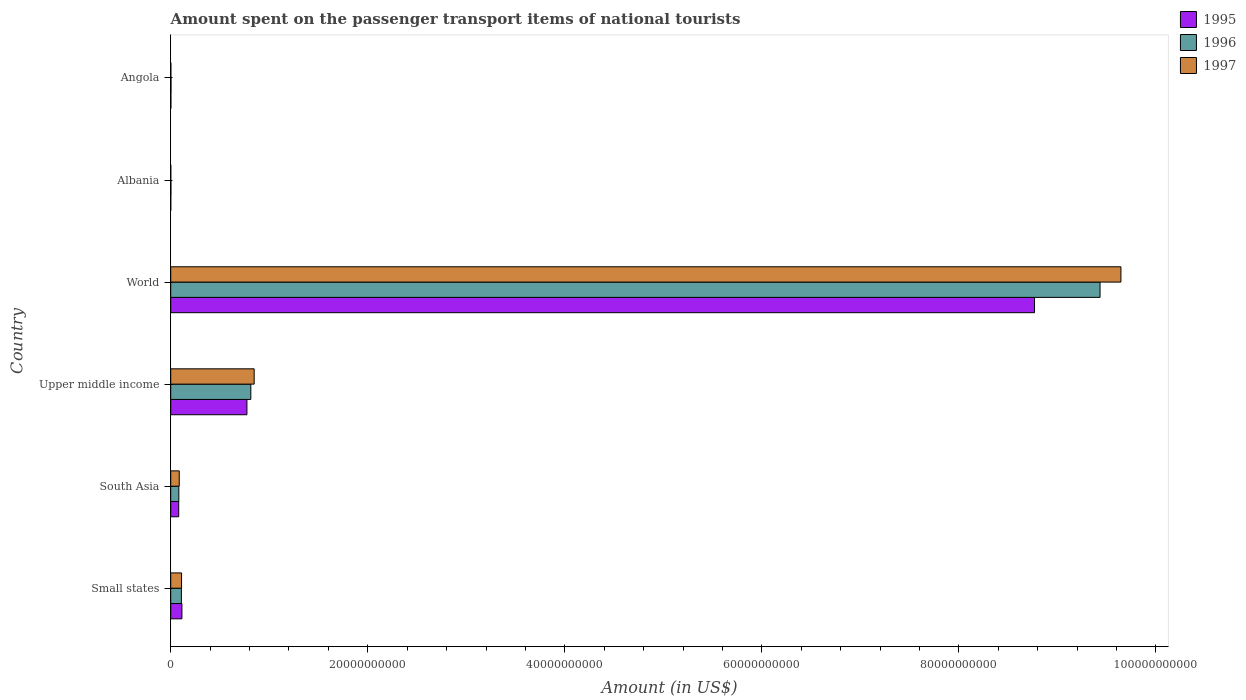How many groups of bars are there?
Ensure brevity in your answer.  6. Are the number of bars on each tick of the Y-axis equal?
Provide a succinct answer. Yes. How many bars are there on the 5th tick from the bottom?
Keep it short and to the point. 3. What is the amount spent on the passenger transport items of national tourists in 1995 in Upper middle income?
Provide a succinct answer. 7.73e+09. Across all countries, what is the maximum amount spent on the passenger transport items of national tourists in 1995?
Offer a terse response. 8.77e+1. Across all countries, what is the minimum amount spent on the passenger transport items of national tourists in 1996?
Keep it short and to the point. 1.68e+07. In which country was the amount spent on the passenger transport items of national tourists in 1996 minimum?
Offer a terse response. Albania. What is the total amount spent on the passenger transport items of national tourists in 1997 in the graph?
Your response must be concise. 1.07e+11. What is the difference between the amount spent on the passenger transport items of national tourists in 1996 in Albania and that in Upper middle income?
Your response must be concise. -8.11e+09. What is the difference between the amount spent on the passenger transport items of national tourists in 1997 in Upper middle income and the amount spent on the passenger transport items of national tourists in 1995 in Small states?
Ensure brevity in your answer.  7.33e+09. What is the average amount spent on the passenger transport items of national tourists in 1995 per country?
Your answer should be compact. 1.62e+1. What is the difference between the amount spent on the passenger transport items of national tourists in 1996 and amount spent on the passenger transport items of national tourists in 1997 in South Asia?
Provide a short and direct response. -4.25e+07. In how many countries, is the amount spent on the passenger transport items of national tourists in 1996 greater than 68000000000 US$?
Your response must be concise. 1. What is the ratio of the amount spent on the passenger transport items of national tourists in 1995 in Angola to that in South Asia?
Your answer should be compact. 0.02. Is the amount spent on the passenger transport items of national tourists in 1995 in Angola less than that in Upper middle income?
Give a very brief answer. Yes. Is the difference between the amount spent on the passenger transport items of national tourists in 1996 in Angola and Upper middle income greater than the difference between the amount spent on the passenger transport items of national tourists in 1997 in Angola and Upper middle income?
Your answer should be very brief. Yes. What is the difference between the highest and the second highest amount spent on the passenger transport items of national tourists in 1996?
Provide a succinct answer. 8.62e+1. What is the difference between the highest and the lowest amount spent on the passenger transport items of national tourists in 1995?
Offer a very short reply. 8.77e+1. Is the sum of the amount spent on the passenger transport items of national tourists in 1997 in Small states and World greater than the maximum amount spent on the passenger transport items of national tourists in 1996 across all countries?
Ensure brevity in your answer.  Yes. What does the 1st bar from the top in Small states represents?
Give a very brief answer. 1997. Is it the case that in every country, the sum of the amount spent on the passenger transport items of national tourists in 1996 and amount spent on the passenger transport items of national tourists in 1995 is greater than the amount spent on the passenger transport items of national tourists in 1997?
Your answer should be very brief. Yes. How many bars are there?
Give a very brief answer. 18. Are all the bars in the graph horizontal?
Your response must be concise. Yes. How many countries are there in the graph?
Your answer should be very brief. 6. What is the difference between two consecutive major ticks on the X-axis?
Your response must be concise. 2.00e+1. Are the values on the major ticks of X-axis written in scientific E-notation?
Your answer should be very brief. No. Does the graph contain any zero values?
Provide a short and direct response. No. Where does the legend appear in the graph?
Your response must be concise. Top right. How many legend labels are there?
Offer a very short reply. 3. What is the title of the graph?
Your response must be concise. Amount spent on the passenger transport items of national tourists. What is the label or title of the Y-axis?
Make the answer very short. Country. What is the Amount (in US$) of 1995 in Small states?
Your response must be concise. 1.14e+09. What is the Amount (in US$) of 1996 in Small states?
Ensure brevity in your answer.  1.08e+09. What is the Amount (in US$) of 1997 in Small states?
Provide a succinct answer. 1.10e+09. What is the Amount (in US$) in 1995 in South Asia?
Keep it short and to the point. 8.12e+08. What is the Amount (in US$) in 1996 in South Asia?
Your answer should be compact. 8.23e+08. What is the Amount (in US$) in 1997 in South Asia?
Ensure brevity in your answer.  8.66e+08. What is the Amount (in US$) of 1995 in Upper middle income?
Your answer should be very brief. 7.73e+09. What is the Amount (in US$) of 1996 in Upper middle income?
Give a very brief answer. 8.13e+09. What is the Amount (in US$) of 1997 in Upper middle income?
Provide a succinct answer. 8.47e+09. What is the Amount (in US$) in 1995 in World?
Your response must be concise. 8.77e+1. What is the Amount (in US$) in 1996 in World?
Make the answer very short. 9.43e+1. What is the Amount (in US$) in 1997 in World?
Keep it short and to the point. 9.64e+1. What is the Amount (in US$) of 1995 in Albania?
Your answer should be compact. 5.40e+06. What is the Amount (in US$) of 1996 in Albania?
Offer a very short reply. 1.68e+07. What is the Amount (in US$) of 1997 in Albania?
Your answer should be compact. 6.60e+06. What is the Amount (in US$) in 1995 in Angola?
Provide a short and direct response. 1.70e+07. What is the Amount (in US$) of 1996 in Angola?
Make the answer very short. 2.90e+07. What is the Amount (in US$) in 1997 in Angola?
Your response must be concise. 1.50e+07. Across all countries, what is the maximum Amount (in US$) in 1995?
Keep it short and to the point. 8.77e+1. Across all countries, what is the maximum Amount (in US$) of 1996?
Keep it short and to the point. 9.43e+1. Across all countries, what is the maximum Amount (in US$) in 1997?
Offer a terse response. 9.64e+1. Across all countries, what is the minimum Amount (in US$) of 1995?
Provide a succinct answer. 5.40e+06. Across all countries, what is the minimum Amount (in US$) in 1996?
Provide a short and direct response. 1.68e+07. Across all countries, what is the minimum Amount (in US$) in 1997?
Your answer should be very brief. 6.60e+06. What is the total Amount (in US$) in 1995 in the graph?
Your answer should be compact. 9.74e+1. What is the total Amount (in US$) of 1996 in the graph?
Keep it short and to the point. 1.04e+11. What is the total Amount (in US$) in 1997 in the graph?
Provide a succinct answer. 1.07e+11. What is the difference between the Amount (in US$) in 1995 in Small states and that in South Asia?
Offer a very short reply. 3.25e+08. What is the difference between the Amount (in US$) in 1996 in Small states and that in South Asia?
Give a very brief answer. 2.60e+08. What is the difference between the Amount (in US$) in 1997 in Small states and that in South Asia?
Your response must be concise. 2.35e+08. What is the difference between the Amount (in US$) in 1995 in Small states and that in Upper middle income?
Give a very brief answer. -6.60e+09. What is the difference between the Amount (in US$) of 1996 in Small states and that in Upper middle income?
Provide a succinct answer. -7.05e+09. What is the difference between the Amount (in US$) in 1997 in Small states and that in Upper middle income?
Provide a short and direct response. -7.37e+09. What is the difference between the Amount (in US$) in 1995 in Small states and that in World?
Your response must be concise. -8.65e+1. What is the difference between the Amount (in US$) of 1996 in Small states and that in World?
Offer a terse response. -9.32e+1. What is the difference between the Amount (in US$) of 1997 in Small states and that in World?
Provide a succinct answer. -9.53e+1. What is the difference between the Amount (in US$) of 1995 in Small states and that in Albania?
Make the answer very short. 1.13e+09. What is the difference between the Amount (in US$) in 1996 in Small states and that in Albania?
Your answer should be very brief. 1.07e+09. What is the difference between the Amount (in US$) of 1997 in Small states and that in Albania?
Your answer should be compact. 1.09e+09. What is the difference between the Amount (in US$) of 1995 in Small states and that in Angola?
Provide a short and direct response. 1.12e+09. What is the difference between the Amount (in US$) in 1996 in Small states and that in Angola?
Your answer should be very brief. 1.05e+09. What is the difference between the Amount (in US$) of 1997 in Small states and that in Angola?
Keep it short and to the point. 1.09e+09. What is the difference between the Amount (in US$) of 1995 in South Asia and that in Upper middle income?
Offer a terse response. -6.92e+09. What is the difference between the Amount (in US$) of 1996 in South Asia and that in Upper middle income?
Offer a terse response. -7.31e+09. What is the difference between the Amount (in US$) in 1997 in South Asia and that in Upper middle income?
Keep it short and to the point. -7.60e+09. What is the difference between the Amount (in US$) in 1995 in South Asia and that in World?
Keep it short and to the point. -8.69e+1. What is the difference between the Amount (in US$) of 1996 in South Asia and that in World?
Your response must be concise. -9.35e+1. What is the difference between the Amount (in US$) of 1997 in South Asia and that in World?
Offer a terse response. -9.56e+1. What is the difference between the Amount (in US$) of 1995 in South Asia and that in Albania?
Provide a short and direct response. 8.07e+08. What is the difference between the Amount (in US$) of 1996 in South Asia and that in Albania?
Keep it short and to the point. 8.06e+08. What is the difference between the Amount (in US$) of 1997 in South Asia and that in Albania?
Provide a succinct answer. 8.59e+08. What is the difference between the Amount (in US$) in 1995 in South Asia and that in Angola?
Ensure brevity in your answer.  7.95e+08. What is the difference between the Amount (in US$) in 1996 in South Asia and that in Angola?
Provide a short and direct response. 7.94e+08. What is the difference between the Amount (in US$) in 1997 in South Asia and that in Angola?
Offer a very short reply. 8.51e+08. What is the difference between the Amount (in US$) of 1995 in Upper middle income and that in World?
Your answer should be very brief. -7.99e+1. What is the difference between the Amount (in US$) in 1996 in Upper middle income and that in World?
Your response must be concise. -8.62e+1. What is the difference between the Amount (in US$) in 1997 in Upper middle income and that in World?
Keep it short and to the point. -8.80e+1. What is the difference between the Amount (in US$) of 1995 in Upper middle income and that in Albania?
Your answer should be compact. 7.73e+09. What is the difference between the Amount (in US$) in 1996 in Upper middle income and that in Albania?
Keep it short and to the point. 8.11e+09. What is the difference between the Amount (in US$) in 1997 in Upper middle income and that in Albania?
Give a very brief answer. 8.46e+09. What is the difference between the Amount (in US$) of 1995 in Upper middle income and that in Angola?
Provide a short and direct response. 7.72e+09. What is the difference between the Amount (in US$) of 1996 in Upper middle income and that in Angola?
Your response must be concise. 8.10e+09. What is the difference between the Amount (in US$) of 1997 in Upper middle income and that in Angola?
Keep it short and to the point. 8.45e+09. What is the difference between the Amount (in US$) in 1995 in World and that in Albania?
Offer a very short reply. 8.77e+1. What is the difference between the Amount (in US$) of 1996 in World and that in Albania?
Offer a very short reply. 9.43e+1. What is the difference between the Amount (in US$) in 1997 in World and that in Albania?
Provide a succinct answer. 9.64e+1. What is the difference between the Amount (in US$) in 1995 in World and that in Angola?
Offer a terse response. 8.77e+1. What is the difference between the Amount (in US$) in 1996 in World and that in Angola?
Your response must be concise. 9.43e+1. What is the difference between the Amount (in US$) in 1997 in World and that in Angola?
Offer a terse response. 9.64e+1. What is the difference between the Amount (in US$) in 1995 in Albania and that in Angola?
Your answer should be very brief. -1.16e+07. What is the difference between the Amount (in US$) of 1996 in Albania and that in Angola?
Offer a terse response. -1.22e+07. What is the difference between the Amount (in US$) of 1997 in Albania and that in Angola?
Your response must be concise. -8.40e+06. What is the difference between the Amount (in US$) of 1995 in Small states and the Amount (in US$) of 1996 in South Asia?
Your answer should be compact. 3.15e+08. What is the difference between the Amount (in US$) in 1995 in Small states and the Amount (in US$) in 1997 in South Asia?
Make the answer very short. 2.72e+08. What is the difference between the Amount (in US$) in 1996 in Small states and the Amount (in US$) in 1997 in South Asia?
Ensure brevity in your answer.  2.18e+08. What is the difference between the Amount (in US$) in 1995 in Small states and the Amount (in US$) in 1996 in Upper middle income?
Offer a terse response. -6.99e+09. What is the difference between the Amount (in US$) in 1995 in Small states and the Amount (in US$) in 1997 in Upper middle income?
Ensure brevity in your answer.  -7.33e+09. What is the difference between the Amount (in US$) of 1996 in Small states and the Amount (in US$) of 1997 in Upper middle income?
Provide a succinct answer. -7.39e+09. What is the difference between the Amount (in US$) in 1995 in Small states and the Amount (in US$) in 1996 in World?
Offer a very short reply. -9.32e+1. What is the difference between the Amount (in US$) of 1995 in Small states and the Amount (in US$) of 1997 in World?
Ensure brevity in your answer.  -9.53e+1. What is the difference between the Amount (in US$) of 1996 in Small states and the Amount (in US$) of 1997 in World?
Ensure brevity in your answer.  -9.54e+1. What is the difference between the Amount (in US$) of 1995 in Small states and the Amount (in US$) of 1996 in Albania?
Your answer should be compact. 1.12e+09. What is the difference between the Amount (in US$) of 1995 in Small states and the Amount (in US$) of 1997 in Albania?
Provide a short and direct response. 1.13e+09. What is the difference between the Amount (in US$) in 1996 in Small states and the Amount (in US$) in 1997 in Albania?
Provide a succinct answer. 1.08e+09. What is the difference between the Amount (in US$) in 1995 in Small states and the Amount (in US$) in 1996 in Angola?
Provide a succinct answer. 1.11e+09. What is the difference between the Amount (in US$) in 1995 in Small states and the Amount (in US$) in 1997 in Angola?
Give a very brief answer. 1.12e+09. What is the difference between the Amount (in US$) in 1996 in Small states and the Amount (in US$) in 1997 in Angola?
Offer a terse response. 1.07e+09. What is the difference between the Amount (in US$) of 1995 in South Asia and the Amount (in US$) of 1996 in Upper middle income?
Offer a terse response. -7.32e+09. What is the difference between the Amount (in US$) of 1995 in South Asia and the Amount (in US$) of 1997 in Upper middle income?
Offer a terse response. -7.66e+09. What is the difference between the Amount (in US$) of 1996 in South Asia and the Amount (in US$) of 1997 in Upper middle income?
Make the answer very short. -7.65e+09. What is the difference between the Amount (in US$) in 1995 in South Asia and the Amount (in US$) in 1996 in World?
Offer a terse response. -9.35e+1. What is the difference between the Amount (in US$) in 1995 in South Asia and the Amount (in US$) in 1997 in World?
Provide a short and direct response. -9.56e+1. What is the difference between the Amount (in US$) of 1996 in South Asia and the Amount (in US$) of 1997 in World?
Your response must be concise. -9.56e+1. What is the difference between the Amount (in US$) in 1995 in South Asia and the Amount (in US$) in 1996 in Albania?
Provide a short and direct response. 7.95e+08. What is the difference between the Amount (in US$) of 1995 in South Asia and the Amount (in US$) of 1997 in Albania?
Provide a succinct answer. 8.05e+08. What is the difference between the Amount (in US$) of 1996 in South Asia and the Amount (in US$) of 1997 in Albania?
Provide a succinct answer. 8.16e+08. What is the difference between the Amount (in US$) of 1995 in South Asia and the Amount (in US$) of 1996 in Angola?
Ensure brevity in your answer.  7.83e+08. What is the difference between the Amount (in US$) of 1995 in South Asia and the Amount (in US$) of 1997 in Angola?
Your answer should be compact. 7.97e+08. What is the difference between the Amount (in US$) in 1996 in South Asia and the Amount (in US$) in 1997 in Angola?
Keep it short and to the point. 8.08e+08. What is the difference between the Amount (in US$) of 1995 in Upper middle income and the Amount (in US$) of 1996 in World?
Provide a succinct answer. -8.66e+1. What is the difference between the Amount (in US$) of 1995 in Upper middle income and the Amount (in US$) of 1997 in World?
Give a very brief answer. -8.87e+1. What is the difference between the Amount (in US$) in 1996 in Upper middle income and the Amount (in US$) in 1997 in World?
Provide a succinct answer. -8.83e+1. What is the difference between the Amount (in US$) of 1995 in Upper middle income and the Amount (in US$) of 1996 in Albania?
Keep it short and to the point. 7.72e+09. What is the difference between the Amount (in US$) of 1995 in Upper middle income and the Amount (in US$) of 1997 in Albania?
Your answer should be very brief. 7.73e+09. What is the difference between the Amount (in US$) of 1996 in Upper middle income and the Amount (in US$) of 1997 in Albania?
Your answer should be very brief. 8.12e+09. What is the difference between the Amount (in US$) of 1995 in Upper middle income and the Amount (in US$) of 1996 in Angola?
Your answer should be very brief. 7.70e+09. What is the difference between the Amount (in US$) of 1995 in Upper middle income and the Amount (in US$) of 1997 in Angola?
Your answer should be compact. 7.72e+09. What is the difference between the Amount (in US$) of 1996 in Upper middle income and the Amount (in US$) of 1997 in Angola?
Keep it short and to the point. 8.12e+09. What is the difference between the Amount (in US$) of 1995 in World and the Amount (in US$) of 1996 in Albania?
Your answer should be very brief. 8.77e+1. What is the difference between the Amount (in US$) in 1995 in World and the Amount (in US$) in 1997 in Albania?
Ensure brevity in your answer.  8.77e+1. What is the difference between the Amount (in US$) in 1996 in World and the Amount (in US$) in 1997 in Albania?
Offer a terse response. 9.43e+1. What is the difference between the Amount (in US$) of 1995 in World and the Amount (in US$) of 1996 in Angola?
Provide a short and direct response. 8.76e+1. What is the difference between the Amount (in US$) of 1995 in World and the Amount (in US$) of 1997 in Angola?
Provide a succinct answer. 8.77e+1. What is the difference between the Amount (in US$) of 1996 in World and the Amount (in US$) of 1997 in Angola?
Make the answer very short. 9.43e+1. What is the difference between the Amount (in US$) of 1995 in Albania and the Amount (in US$) of 1996 in Angola?
Make the answer very short. -2.36e+07. What is the difference between the Amount (in US$) of 1995 in Albania and the Amount (in US$) of 1997 in Angola?
Provide a short and direct response. -9.60e+06. What is the difference between the Amount (in US$) in 1996 in Albania and the Amount (in US$) in 1997 in Angola?
Keep it short and to the point. 1.80e+06. What is the average Amount (in US$) of 1995 per country?
Offer a terse response. 1.62e+1. What is the average Amount (in US$) of 1996 per country?
Your response must be concise. 1.74e+1. What is the average Amount (in US$) of 1997 per country?
Your answer should be very brief. 1.78e+1. What is the difference between the Amount (in US$) in 1995 and Amount (in US$) in 1996 in Small states?
Make the answer very short. 5.44e+07. What is the difference between the Amount (in US$) in 1995 and Amount (in US$) in 1997 in Small states?
Your answer should be very brief. 3.69e+07. What is the difference between the Amount (in US$) of 1996 and Amount (in US$) of 1997 in Small states?
Ensure brevity in your answer.  -1.75e+07. What is the difference between the Amount (in US$) in 1995 and Amount (in US$) in 1996 in South Asia?
Your answer should be compact. -1.09e+07. What is the difference between the Amount (in US$) in 1995 and Amount (in US$) in 1997 in South Asia?
Provide a succinct answer. -5.35e+07. What is the difference between the Amount (in US$) in 1996 and Amount (in US$) in 1997 in South Asia?
Offer a very short reply. -4.25e+07. What is the difference between the Amount (in US$) of 1995 and Amount (in US$) of 1996 in Upper middle income?
Give a very brief answer. -3.97e+08. What is the difference between the Amount (in US$) in 1995 and Amount (in US$) in 1997 in Upper middle income?
Give a very brief answer. -7.36e+08. What is the difference between the Amount (in US$) of 1996 and Amount (in US$) of 1997 in Upper middle income?
Offer a very short reply. -3.39e+08. What is the difference between the Amount (in US$) of 1995 and Amount (in US$) of 1996 in World?
Make the answer very short. -6.65e+09. What is the difference between the Amount (in US$) of 1995 and Amount (in US$) of 1997 in World?
Provide a short and direct response. -8.77e+09. What is the difference between the Amount (in US$) of 1996 and Amount (in US$) of 1997 in World?
Offer a very short reply. -2.12e+09. What is the difference between the Amount (in US$) of 1995 and Amount (in US$) of 1996 in Albania?
Your response must be concise. -1.14e+07. What is the difference between the Amount (in US$) in 1995 and Amount (in US$) in 1997 in Albania?
Give a very brief answer. -1.20e+06. What is the difference between the Amount (in US$) in 1996 and Amount (in US$) in 1997 in Albania?
Make the answer very short. 1.02e+07. What is the difference between the Amount (in US$) of 1995 and Amount (in US$) of 1996 in Angola?
Provide a short and direct response. -1.20e+07. What is the difference between the Amount (in US$) in 1996 and Amount (in US$) in 1997 in Angola?
Your response must be concise. 1.40e+07. What is the ratio of the Amount (in US$) in 1995 in Small states to that in South Asia?
Offer a very short reply. 1.4. What is the ratio of the Amount (in US$) in 1996 in Small states to that in South Asia?
Give a very brief answer. 1.32. What is the ratio of the Amount (in US$) in 1997 in Small states to that in South Asia?
Your answer should be very brief. 1.27. What is the ratio of the Amount (in US$) of 1995 in Small states to that in Upper middle income?
Your answer should be compact. 0.15. What is the ratio of the Amount (in US$) of 1996 in Small states to that in Upper middle income?
Offer a very short reply. 0.13. What is the ratio of the Amount (in US$) of 1997 in Small states to that in Upper middle income?
Provide a succinct answer. 0.13. What is the ratio of the Amount (in US$) in 1995 in Small states to that in World?
Give a very brief answer. 0.01. What is the ratio of the Amount (in US$) in 1996 in Small states to that in World?
Keep it short and to the point. 0.01. What is the ratio of the Amount (in US$) of 1997 in Small states to that in World?
Offer a very short reply. 0.01. What is the ratio of the Amount (in US$) of 1995 in Small states to that in Albania?
Your answer should be compact. 210.65. What is the ratio of the Amount (in US$) of 1996 in Small states to that in Albania?
Your answer should be compact. 64.47. What is the ratio of the Amount (in US$) in 1997 in Small states to that in Albania?
Offer a very short reply. 166.76. What is the ratio of the Amount (in US$) of 1995 in Small states to that in Angola?
Your answer should be very brief. 66.91. What is the ratio of the Amount (in US$) of 1996 in Small states to that in Angola?
Offer a terse response. 37.35. What is the ratio of the Amount (in US$) in 1997 in Small states to that in Angola?
Offer a terse response. 73.37. What is the ratio of the Amount (in US$) in 1995 in South Asia to that in Upper middle income?
Give a very brief answer. 0.1. What is the ratio of the Amount (in US$) in 1996 in South Asia to that in Upper middle income?
Ensure brevity in your answer.  0.1. What is the ratio of the Amount (in US$) in 1997 in South Asia to that in Upper middle income?
Offer a terse response. 0.1. What is the ratio of the Amount (in US$) in 1995 in South Asia to that in World?
Provide a short and direct response. 0.01. What is the ratio of the Amount (in US$) in 1996 in South Asia to that in World?
Offer a very short reply. 0.01. What is the ratio of the Amount (in US$) of 1997 in South Asia to that in World?
Provide a short and direct response. 0.01. What is the ratio of the Amount (in US$) of 1995 in South Asia to that in Albania?
Give a very brief answer. 150.38. What is the ratio of the Amount (in US$) in 1996 in South Asia to that in Albania?
Offer a very short reply. 48.99. What is the ratio of the Amount (in US$) in 1997 in South Asia to that in Albania?
Keep it short and to the point. 131.14. What is the ratio of the Amount (in US$) in 1995 in South Asia to that in Angola?
Offer a very short reply. 47.77. What is the ratio of the Amount (in US$) of 1996 in South Asia to that in Angola?
Offer a terse response. 28.38. What is the ratio of the Amount (in US$) of 1997 in South Asia to that in Angola?
Your answer should be very brief. 57.7. What is the ratio of the Amount (in US$) of 1995 in Upper middle income to that in World?
Offer a very short reply. 0.09. What is the ratio of the Amount (in US$) in 1996 in Upper middle income to that in World?
Offer a terse response. 0.09. What is the ratio of the Amount (in US$) in 1997 in Upper middle income to that in World?
Keep it short and to the point. 0.09. What is the ratio of the Amount (in US$) of 1995 in Upper middle income to that in Albania?
Your response must be concise. 1432.19. What is the ratio of the Amount (in US$) in 1996 in Upper middle income to that in Albania?
Provide a succinct answer. 483.97. What is the ratio of the Amount (in US$) of 1997 in Upper middle income to that in Albania?
Provide a succinct answer. 1283.31. What is the ratio of the Amount (in US$) in 1995 in Upper middle income to that in Angola?
Offer a very short reply. 454.93. What is the ratio of the Amount (in US$) of 1996 in Upper middle income to that in Angola?
Give a very brief answer. 280.37. What is the ratio of the Amount (in US$) in 1997 in Upper middle income to that in Angola?
Keep it short and to the point. 564.66. What is the ratio of the Amount (in US$) of 1995 in World to that in Albania?
Offer a very short reply. 1.62e+04. What is the ratio of the Amount (in US$) of 1996 in World to that in Albania?
Keep it short and to the point. 5614.52. What is the ratio of the Amount (in US$) of 1997 in World to that in Albania?
Provide a short and direct response. 1.46e+04. What is the ratio of the Amount (in US$) of 1995 in World to that in Angola?
Give a very brief answer. 5157.3. What is the ratio of the Amount (in US$) of 1996 in World to that in Angola?
Give a very brief answer. 3252.55. What is the ratio of the Amount (in US$) in 1997 in World to that in Angola?
Your response must be concise. 6429.47. What is the ratio of the Amount (in US$) of 1995 in Albania to that in Angola?
Your answer should be compact. 0.32. What is the ratio of the Amount (in US$) in 1996 in Albania to that in Angola?
Ensure brevity in your answer.  0.58. What is the ratio of the Amount (in US$) in 1997 in Albania to that in Angola?
Your answer should be very brief. 0.44. What is the difference between the highest and the second highest Amount (in US$) in 1995?
Your answer should be compact. 7.99e+1. What is the difference between the highest and the second highest Amount (in US$) in 1996?
Ensure brevity in your answer.  8.62e+1. What is the difference between the highest and the second highest Amount (in US$) of 1997?
Your answer should be very brief. 8.80e+1. What is the difference between the highest and the lowest Amount (in US$) in 1995?
Your answer should be very brief. 8.77e+1. What is the difference between the highest and the lowest Amount (in US$) of 1996?
Your answer should be very brief. 9.43e+1. What is the difference between the highest and the lowest Amount (in US$) in 1997?
Make the answer very short. 9.64e+1. 